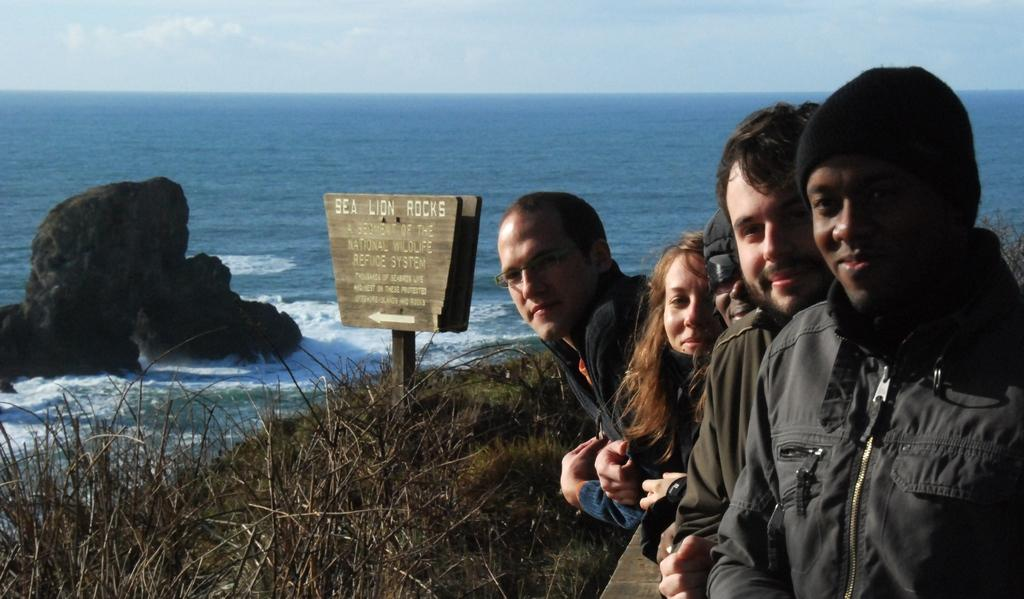What are the people in the image doing? The people in the image are standing and smiling. What can be seen in the background of the image? In the background of the image, there are rocks, sea, sign boards, grass, and the sky. What is the condition of the sky in the image? The sky is visible in the background of the image, and clouds are present. How many cherries are being held by the people in the image? There are no cherries present in the image. What is the middle element of the sign boards in the image? There is no mention of any specific middle element on the sign boards in the image. 